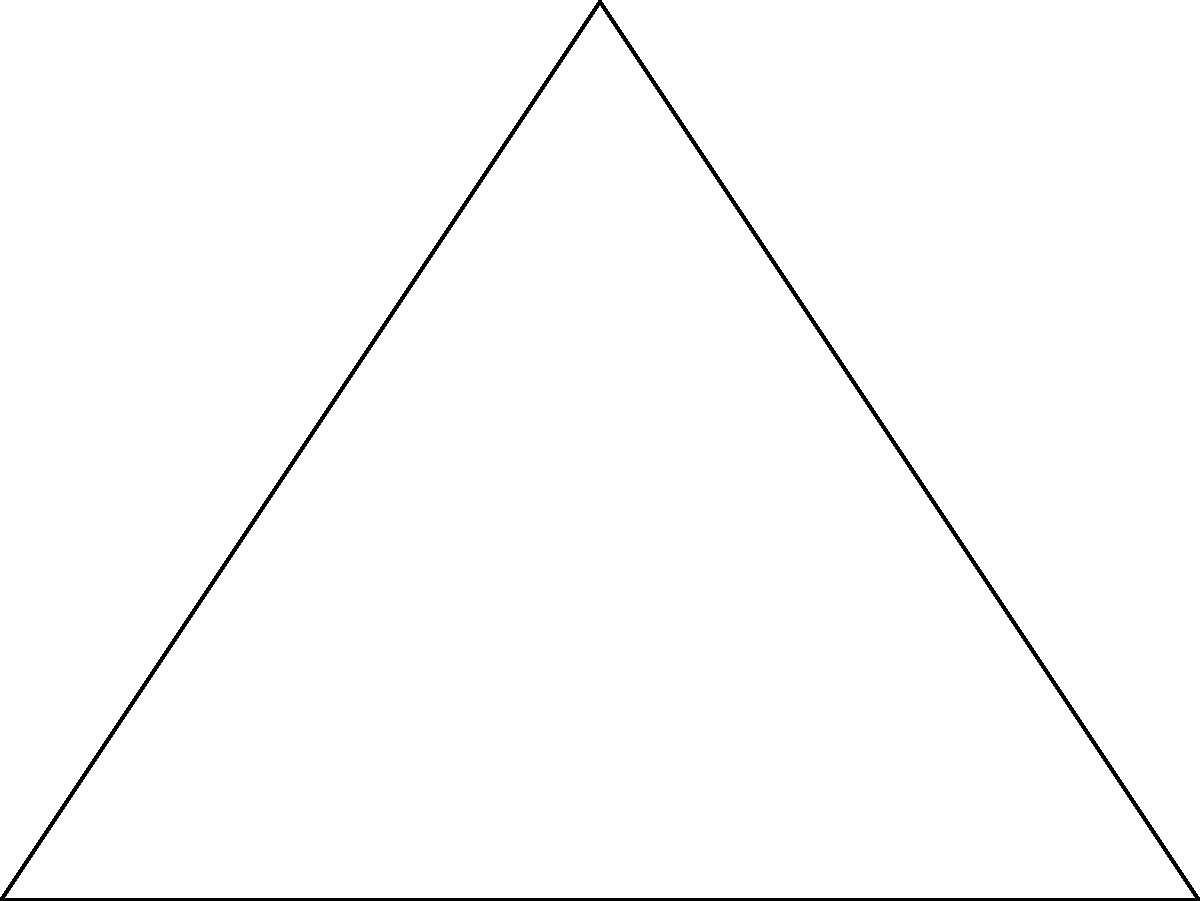During a Hertha BSC match, rising stars Javairô Dilrosun and Daishawn Redan are positioned as shown in the diagram. Dilrosun is at point A, Redan at point B, and they are both aiming towards the goal at point C. If the distance between Dilrosun and Redan is 60 meters, and the distance from Redan to the goal is 45 meters, what is the distance between Dilrosun and the goal? Let's solve this step-by-step using trigonometry:

1) First, we recognize that this forms a right-angled triangle, with the right angle at C.

2) We know two sides of this triangle:
   AB (distance between players) = 60 m
   BC (Redan to goal) = 45 m

3) We need to find AC (Dilrosun to goal).

4) We can use the Pythagorean theorem: $AC^2 = AB^2 + BC^2$

5) Substituting the known values:
   $AC^2 = 60^2 + 45^2$

6) Simplify:
   $AC^2 = 3600 + 2025 = 5625$

7) Take the square root of both sides:
   $AC = \sqrt{5625} = 75$

Therefore, the distance between Dilrosun and the goal is 75 meters.
Answer: 75 meters 